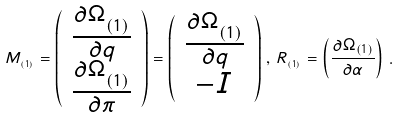Convert formula to latex. <formula><loc_0><loc_0><loc_500><loc_500>M _ { _ { ( 1 ) } } = \left ( \begin{array} { c } { \frac { \partial \Omega _ { _ { ( 1 ) } } } { \partial q } } \\ { \frac { \partial \Omega _ { _ { ( 1 ) } } } { \partial \pi } } \end{array} \right ) = \left ( \begin{array} { c } { \frac { \partial \Omega _ { _ { ( 1 ) } } } { \partial q } } \\ { - I } \end{array} \right ) \, , \, R _ { _ { ( 1 ) } } = \left ( { \frac { \partial \Omega _ { ( 1 ) } } { \partial \alpha } } \right ) \, .</formula> 